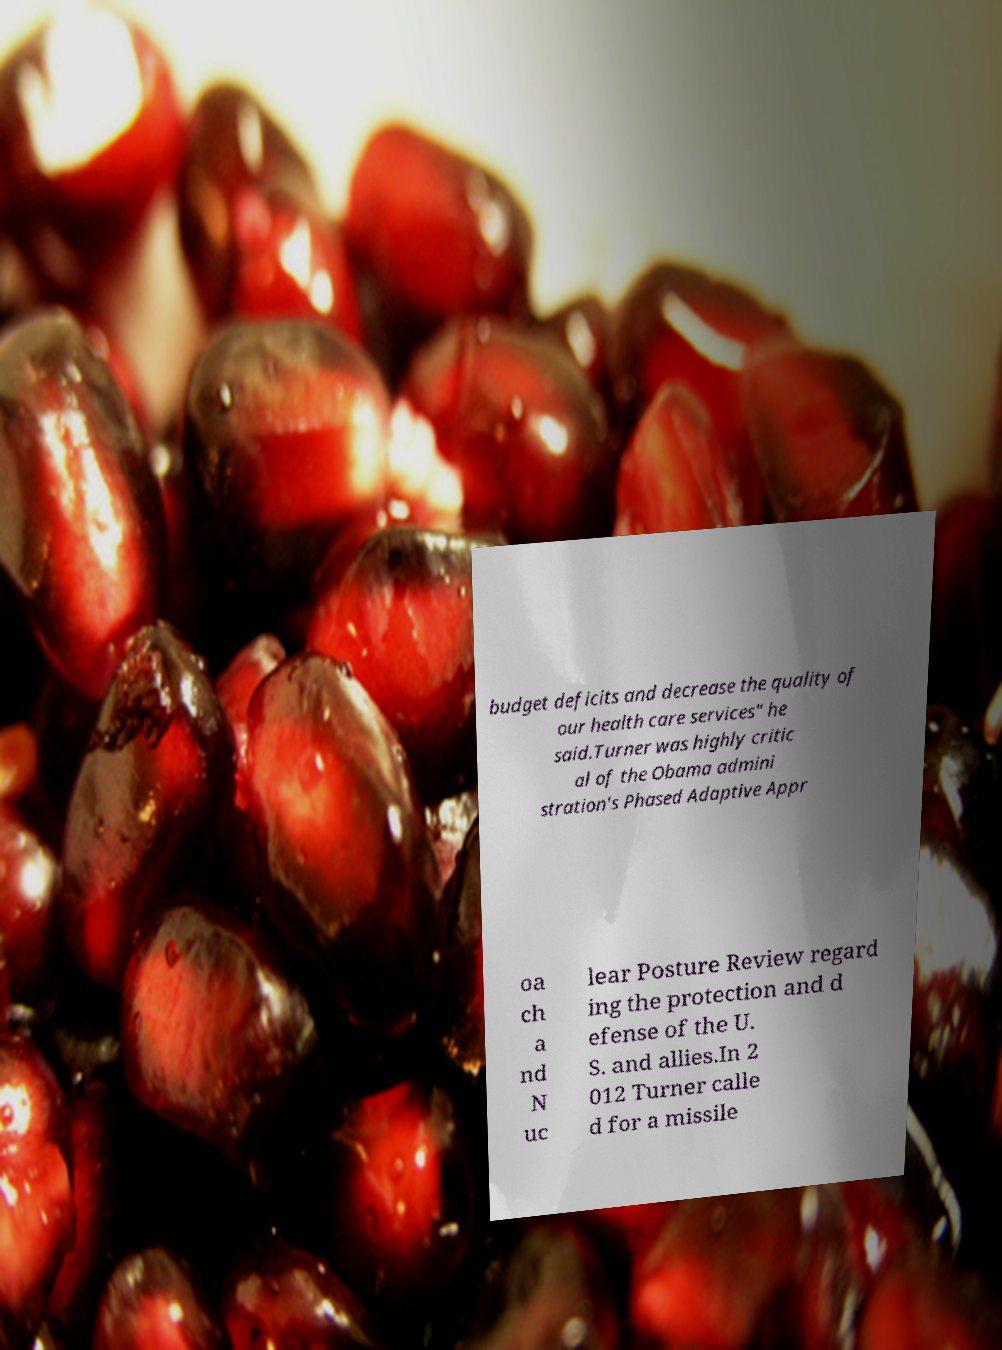Please read and relay the text visible in this image. What does it say? budget deficits and decrease the quality of our health care services" he said.Turner was highly critic al of the Obama admini stration's Phased Adaptive Appr oa ch a nd N uc lear Posture Review regard ing the protection and d efense of the U. S. and allies.In 2 012 Turner calle d for a missile 